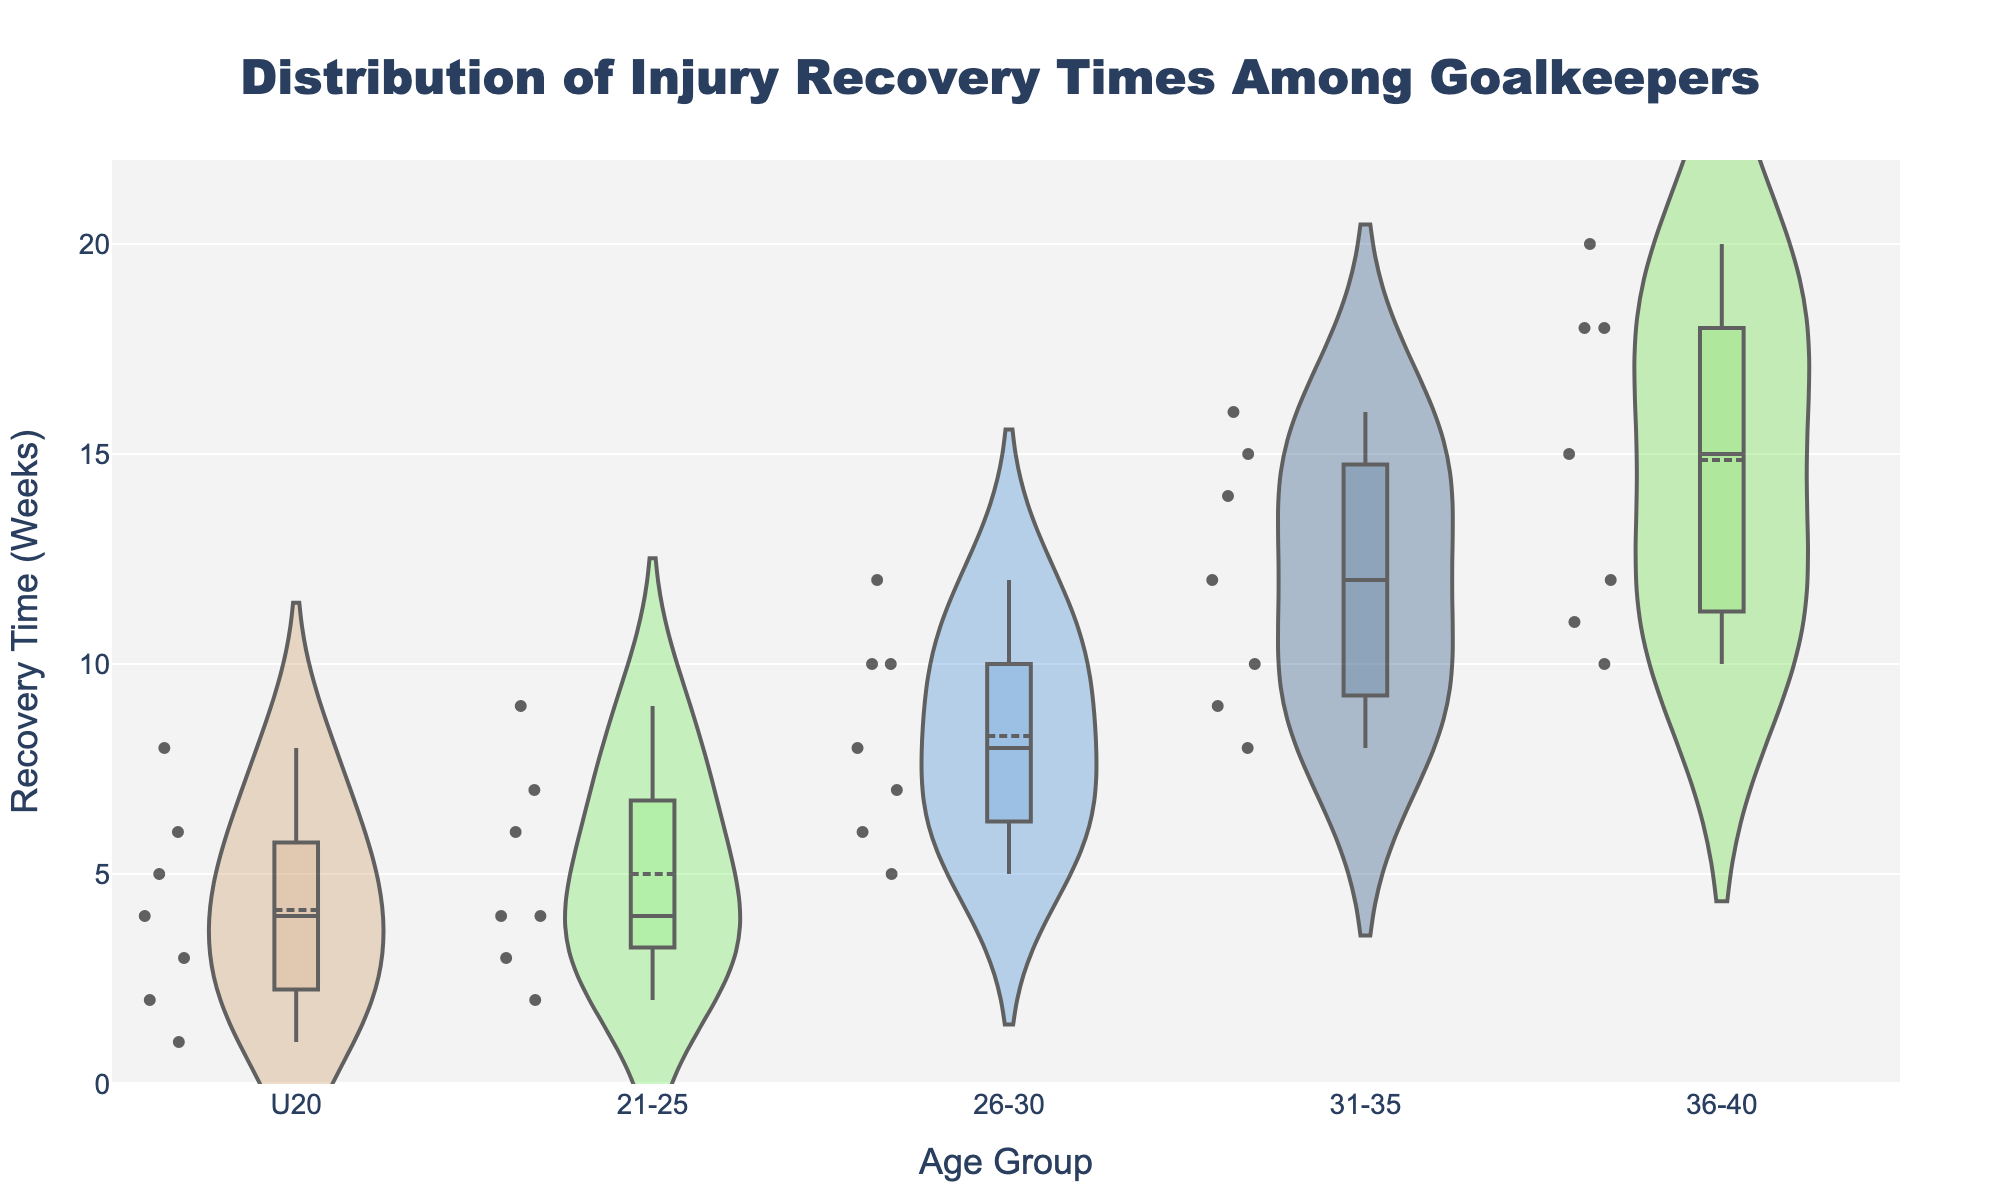What is the title of the figure? The title of the figure is displayed at the top center of the plot. It is usually formatted to give an overview of what the figure represents.
Answer: Distribution of Injury Recovery Times Among Goalkeepers How many age groups are compared in this figure? The number of age groups can be counted by looking at the individual names on the x-axis in the figure.
Answer: 5 Which age group has the shortest median recovery time? To find the median recovery time, look for the horizontal line inside each box plot, which indicates the median value. Compare these lines for the shortest one.
Answer: U20 What is the range of recovery times for the age group 31-35? The range of recovery times in a box plot is indicated by the difference between the minimum and maximum values (whiskers). Look at the bottom and top of the box plot for age group 31-35.
Answer: 8 to 16 weeks Which age group has the overall longest recovery time and what is that time? Look at the maximum whisker value of each age group's box plot to identify the longest recovery time and note the age group it belongs to.
Answer: 36-40, 20 weeks Which age group has the most variation in recovery times? Variation can be observed by the width of the violin plot and the length of the whiskers in the box plot. Wider and longer plots indicate more variation.
Answer: 36-40 What is the mean recovery time for the age group 26-30? The mean recovery time is shown by the white dot inside each violin plot. Identify the position of this dot relative to the y-axis for the age group 26-30.
Answer: 8 weeks How do the recovery times for age group 21-25 compare to those of age group 36-40? Compare the box plots and violin plots for age group 21-25 and 36-40 by observing their spread and central tendency like the median and mean lines.
Answer: 36-40 has longer recovery times For the age group 31-35, how does the recovery time of Groin Strain compare to that of a Concussion? Look at the points within the age group 31-35's violin plot for the specific recovery times of Groin Strain and Concussion. Compare their values.
Answer: Groin Strain (8 weeks) is shorter than Concussion (14 weeks) What can you infer about the recovery time trends as age increases? Observe the general trend in the median and range of recovery times across increasing age groups to infer if recovery times tend to increase, decrease, or remain stable with age.
Answer: Recovery times tend to increase with age 